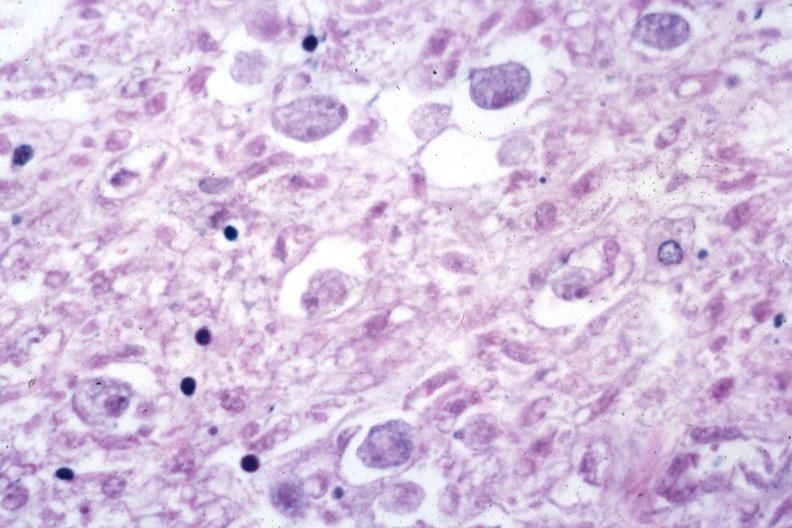s amebiasis present?
Answer the question using a single word or phrase. Yes 